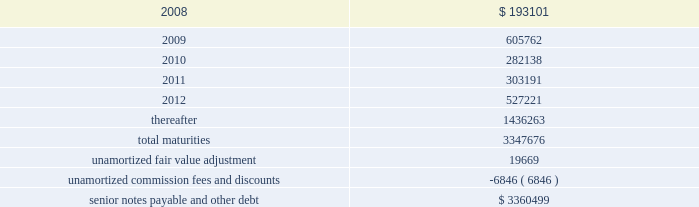Ventas , inc .
Notes to consolidated financial statements 2014 ( continued ) applicable indenture .
The issuers may also redeem the 2015 senior notes , in whole at any time or in part from time to time , on or after june 1 , 2010 at varying redemption prices set forth in the applicable indenture , plus accrued and unpaid interest thereon to the redemption date .
In addition , at any time prior to june 1 , 2008 , the issuers may redeem up to 35% ( 35 % ) of the aggregate principal amount of either or both of the 2010 senior notes and 2015 senior notes with the net cash proceeds from certain equity offerings at redemption prices equal to 106.750% ( 106.750 % ) and 107.125% ( 107.125 % ) , respectively , of the principal amount thereof , plus , in each case , accrued and unpaid interest thereon to the redemption date .
The issuers may redeem the 2014 senior notes , in whole at any time or in part from time to time , ( i ) prior to october 15 , 2009 at a redemption price equal to 100% ( 100 % ) of the principal amount thereof , plus a make-whole premium as described in the applicable indenture and ( ii ) on or after october 15 , 2009 at varying redemption prices set forth in the applicable indenture , plus , in each case , accrued and unpaid interest thereon to the redemption date .
The issuers may redeem the 2009 senior notes and the 2012 senior notes , in whole at any time or in part from time to time , at a redemption price equal to 100% ( 100 % ) of the principal amount thereof , plus accrued and unpaid interest thereon to the redemption date and a make-whole premium as described in the applicable indenture .
If we experience certain kinds of changes of control , the issuers must make an offer to repurchase the senior notes , in whole or in part , at a purchase price in cash equal to 101% ( 101 % ) of the principal amount of the senior notes , plus any accrued and unpaid interest to the date of purchase ; provided , however , that in the event moody 2019s and s&p have confirmed their ratings at ba3 or higher and bb- or higher on the senior notes and certain other conditions are met , this repurchase obligation will not apply .
Mortgages at december 31 , 2007 , we had outstanding 121 mortgage loans totaling $ 1.57 billion that are collateralized by the underlying assets of the properties .
Outstanding principal balances on these loans ranged from $ 0.4 million to $ 59.4 million as of december 31 , 2007 .
The loans generally bear interest at fixed rates ranging from 5.4% ( 5.4 % ) to 8.5% ( 8.5 % ) per annum , except for 15 loans with outstanding principal balances ranging from $ 0.4 million to $ 32.0 million , which bear interest at the lender 2019s variable rates ranging from 3.4% ( 3.4 % ) to 7.3% ( 7.3 % ) per annum as of december 31 , 2007 .
At december 31 , 2007 , the weighted average annual rate on fixed rate debt was 6.5% ( 6.5 % ) and the weighted average annual rate on the variable rate debt was 6.1% ( 6.1 % ) .
The loans had a weighted average maturity of 7.0 years as of december 31 , 2007 .
Sunrise 2019s portion of total debt was $ 157.1 million as of december 31 , scheduled maturities of borrowing arrangements and other provisions as of december 31 , 2007 , our indebtedness had the following maturities ( in thousands ) : .

What percentage of total maturities makes up senior notes payable and other debt? 
Computations: (3347676 / 3360499)
Answer: 0.99618. 